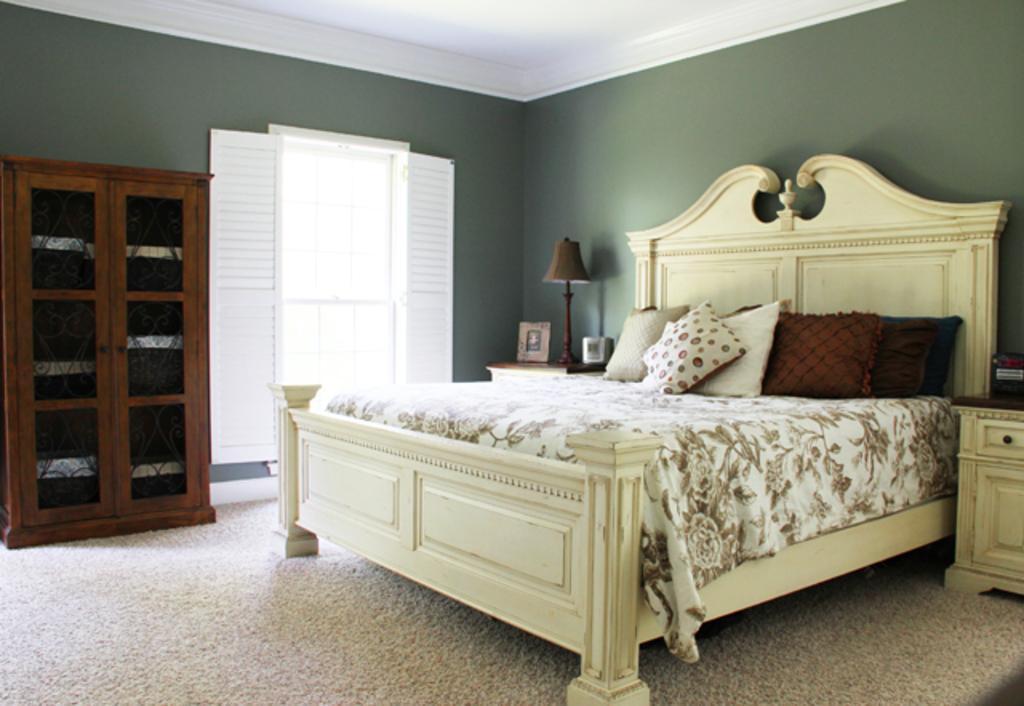Please provide a concise description of this image. There is a cot on which bed some blankets and a pillows were placed. There is a cupboard to the wall here. In a background there is a lamp placed on the table and door here. 